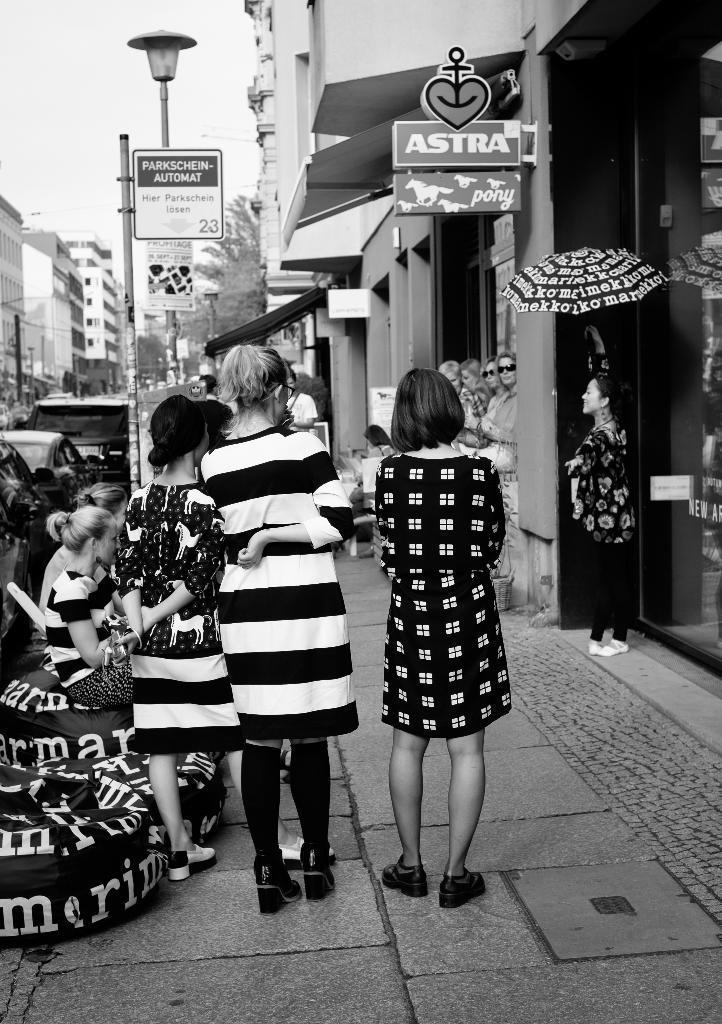Please provide a concise description of this image. This picture shows few people standing and few are seated and we see a woman holding a umbrella in her hand and we see boards to the poles and we see buildings and trees and couple of pole lights. 